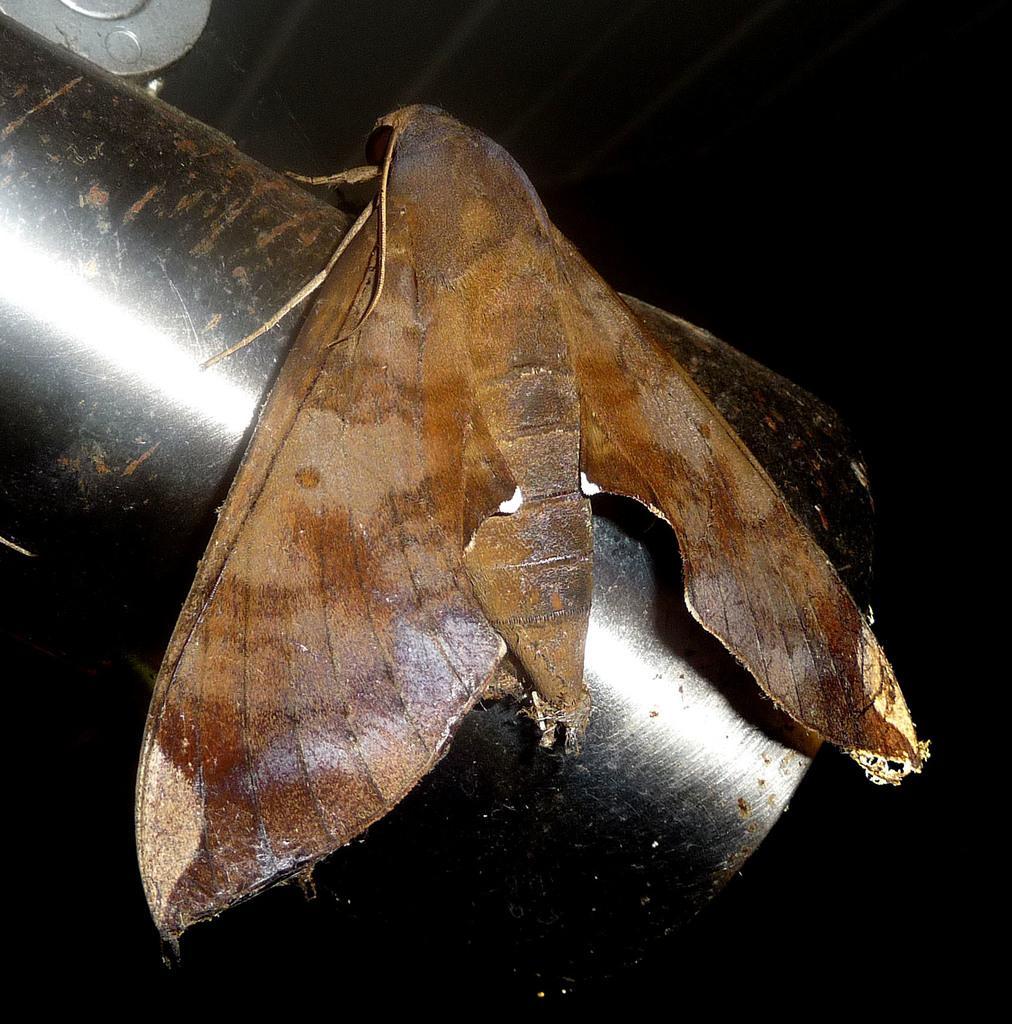How would you summarize this image in a sentence or two? In this image in the front there is an object which is brown in colour and it is on the pipe which is black in colour. 